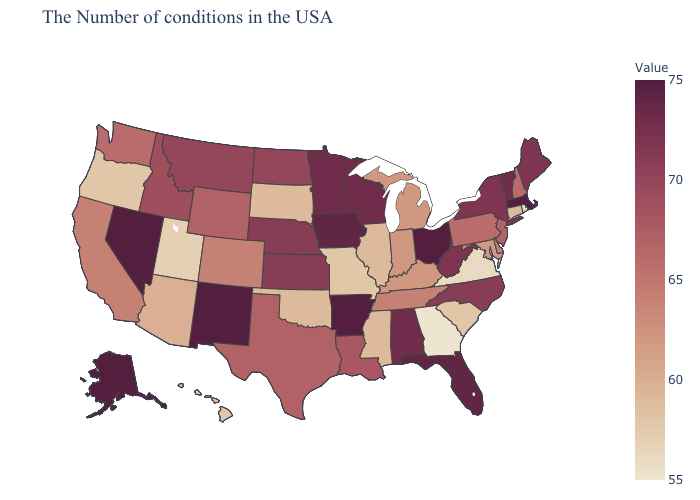Does the map have missing data?
Give a very brief answer. No. Which states hav the highest value in the MidWest?
Concise answer only. Ohio. Does the map have missing data?
Concise answer only. No. Does Nevada have the highest value in the USA?
Quick response, please. Yes. Does Kansas have a lower value than Washington?
Answer briefly. No. 